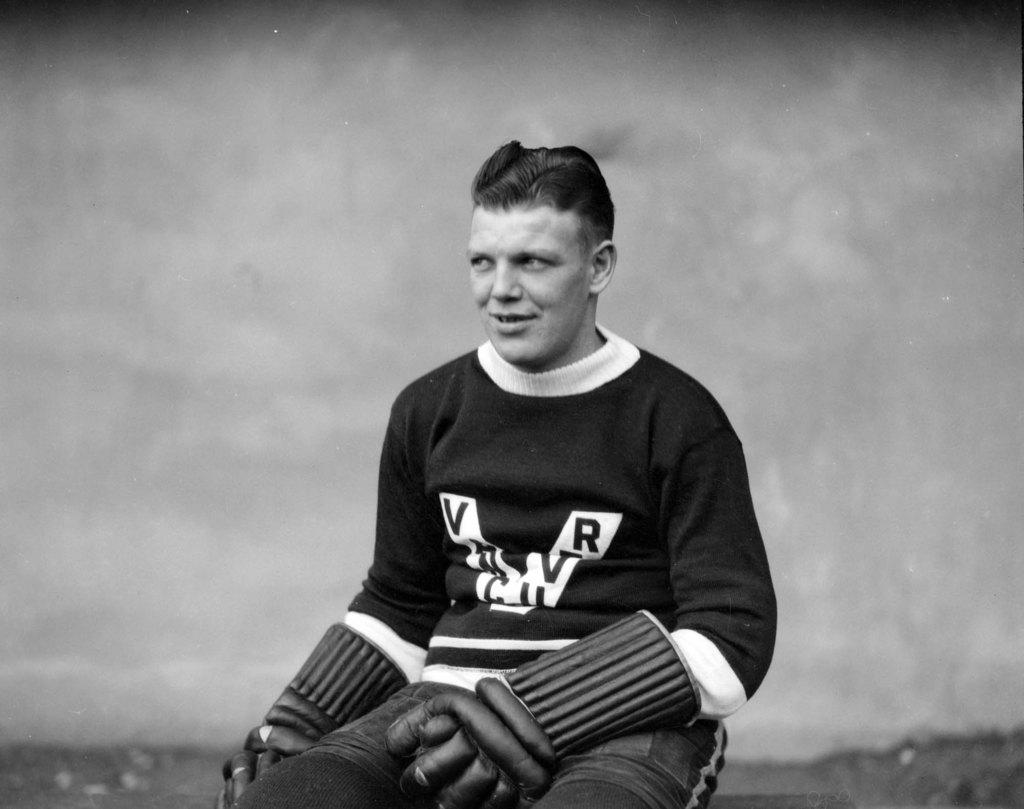<image>
Present a compact description of the photo's key features. A man wearing old fashioned baseball gear has an emblem on his jersey beginning with the letter V. 